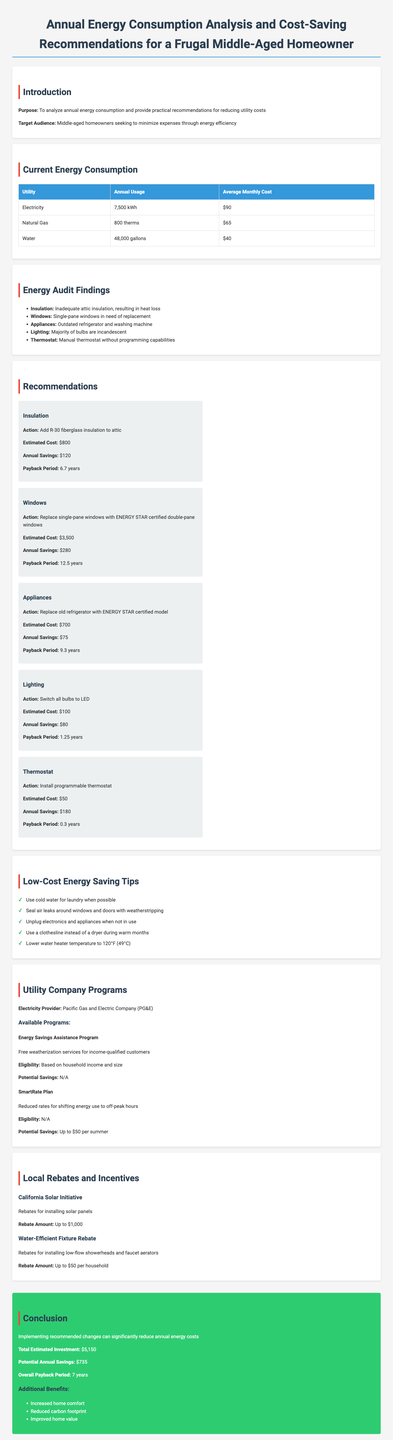What is the annual electricity usage? The annual electricity usage is listed in the Current Energy Consumption section of the document.
Answer: 7,500 kWh What is the average monthly cost of natural gas? The average monthly cost of natural gas can be found under Current Energy Consumption.
Answer: $65 What is one major finding from the energy audit? Information about the energy audit findings can be found in the corresponding section detailing issues with the home.
Answer: Inadequate attic insulation, resulting in heat loss How much can be saved annually by installing a programmable thermostat? The annual savings from installing a programmable thermostat is listed in the Recommendations section.
Answer: $180 What is the total estimated investment for all recommendations? This information is summarized in the Conclusion section of the document.
Answer: $5,150 Which utility company provides available programs? The utility company responsible for the available programs is mentioned in the Utility Company Programs section.
Answer: Pacific Gas and Electric Company (PG&E) What is the payback period for replacing single-pane windows? The payback period for replacing single-pane windows is located in the Recommendations section.
Answer: 12.5 years What benefit comes from implementing the recommended changes? Benefits from implementing the recommendations are listed in the Conclusion section.
Answer: Increased home comfort What is the rebate amount for installing low-flow fixtures? The rebate amount for low-flow fixtures is specified in the Local Rebates and Incentives section.
Answer: Up to $50 per household 